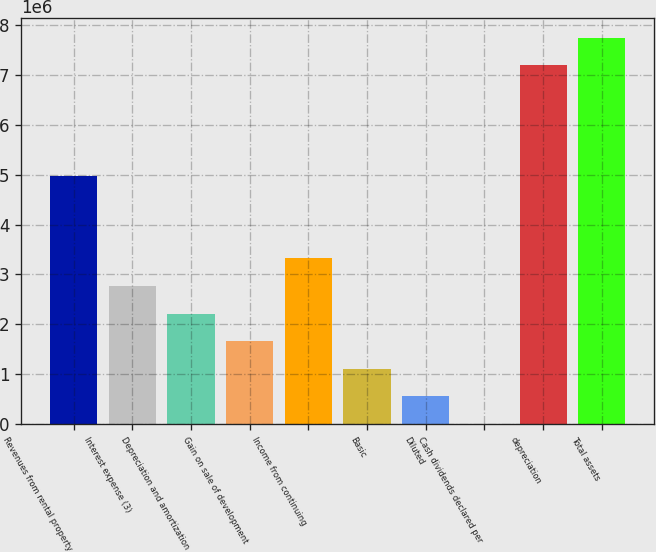Convert chart. <chart><loc_0><loc_0><loc_500><loc_500><bar_chart><fcel>Revenues from rental property<fcel>Interest expense (3)<fcel>Depreciation and amortization<fcel>Gain on sale of development<fcel>Income from continuing<fcel>Basic<fcel>Diluted<fcel>Cash dividends declared per<fcel>depreciation<fcel>Total assets<nl><fcel>4.98117e+06<fcel>2.76732e+06<fcel>2.21386e+06<fcel>1.66039e+06<fcel>3.32078e+06<fcel>1.10693e+06<fcel>553465<fcel>1.27<fcel>7.19503e+06<fcel>7.74849e+06<nl></chart> 